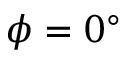<formula> <loc_0><loc_0><loc_500><loc_500>\phi = 0 ^ { \circ }</formula> 